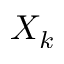Convert formula to latex. <formula><loc_0><loc_0><loc_500><loc_500>X _ { k }</formula> 